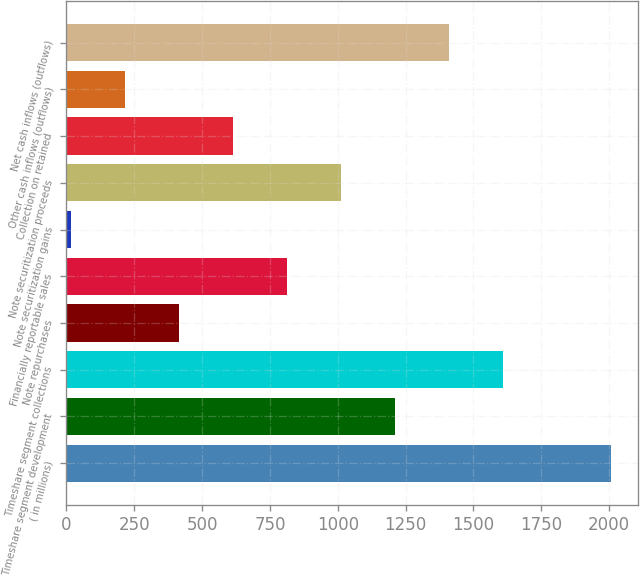<chart> <loc_0><loc_0><loc_500><loc_500><bar_chart><fcel>( in millions)<fcel>Timeshare segment development<fcel>Timeshare segment collections<fcel>Note repurchases<fcel>Financially reportable sales<fcel>Note securitization gains<fcel>Note securitization proceeds<fcel>Collection on retained<fcel>Other cash inflows (outflows)<fcel>Net cash inflows (outflows)<nl><fcel>2008<fcel>1211.2<fcel>1609.6<fcel>414.4<fcel>812.8<fcel>16<fcel>1012<fcel>613.6<fcel>215.2<fcel>1410.4<nl></chart> 